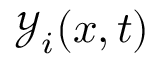<formula> <loc_0><loc_0><loc_500><loc_500>\mathcal { Y } _ { i } ( x , t )</formula> 